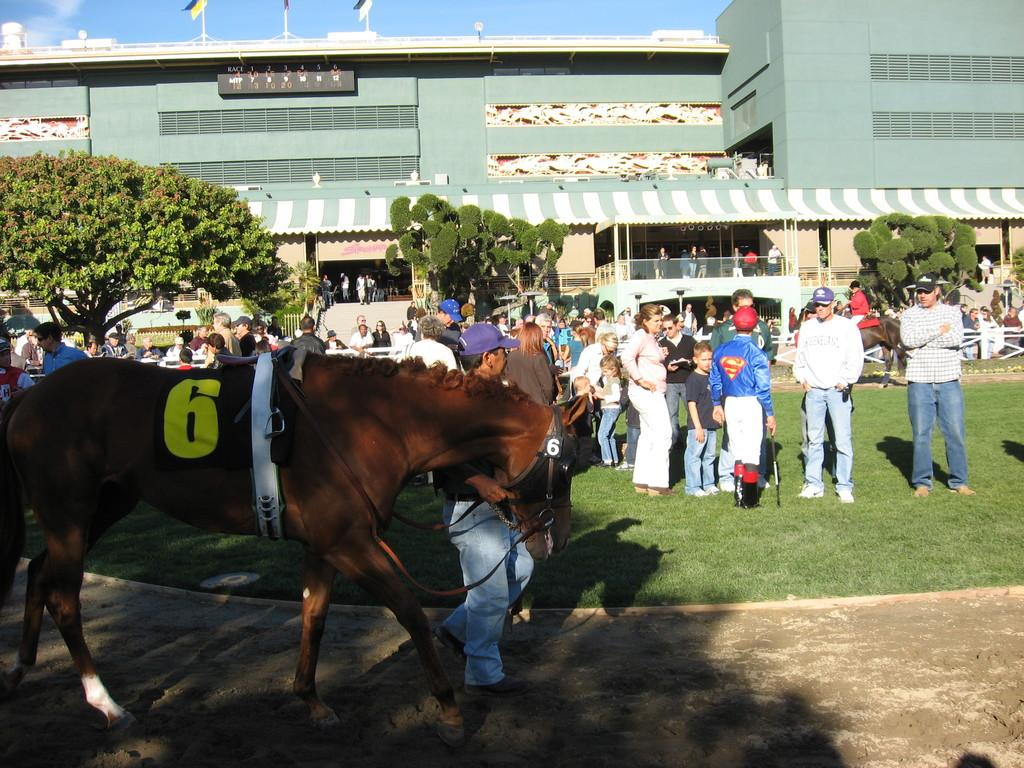Who or what can be seen in the image? There are people and a horse in the image. What type of natural environment is depicted in the image? There are trees and grass in the image. What type of structure is present in the image? There is a building in the image. What are the flag poles used for in the image? The flag poles are used to hold flags in the image. What can be seen in the background of the image? The sky is visible in the background of the image. What type of cover is protecting the people from the sleet in the image? There is no mention of sleet or cover in the image; it features people, a horse, trees, grass, a building, flag poles, boards, and a visible sky. 